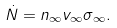Convert formula to latex. <formula><loc_0><loc_0><loc_500><loc_500>\dot { N } = n _ { \infty } v _ { \infty } \sigma _ { \infty } .</formula> 